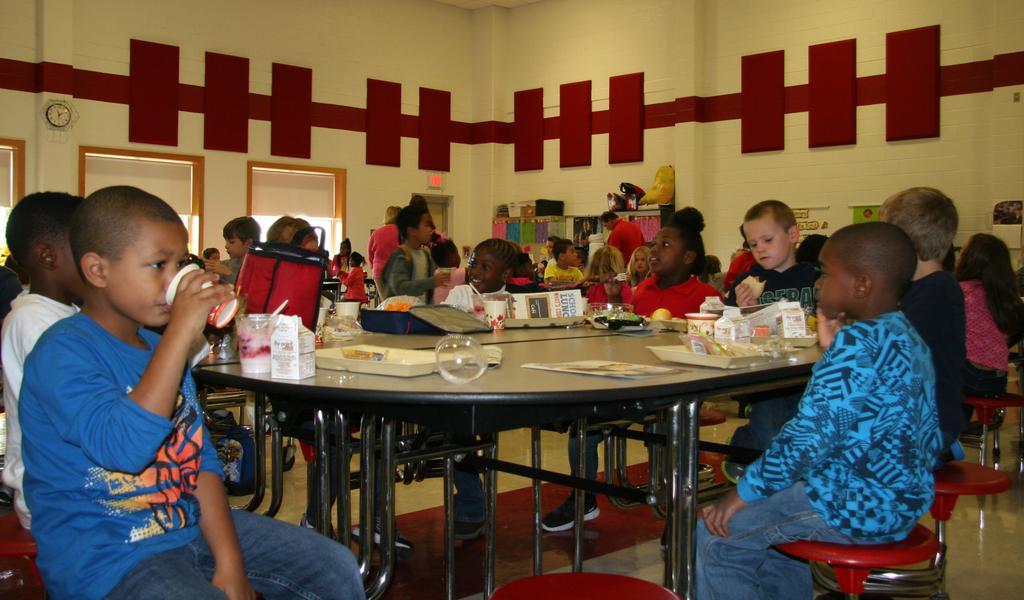How would you summarize this image in a sentence or two? This picture is clicked inside the room. Here, we can see many children sitting on chair and having their food. We can even see a dining table on which glass, plate, lunch boxes, paper and eatables are placed on it. On the right bottom, we can see a boy wearing blue shirt is watching someone on the opposite side. On background, we see clothes or napkins that are hanged to the hangers. Behind that, we see a wall with maroon stripes. To the left of the picture, we can see doors and on the left top, we see watch which is placed on the wall fixed on the wall. 